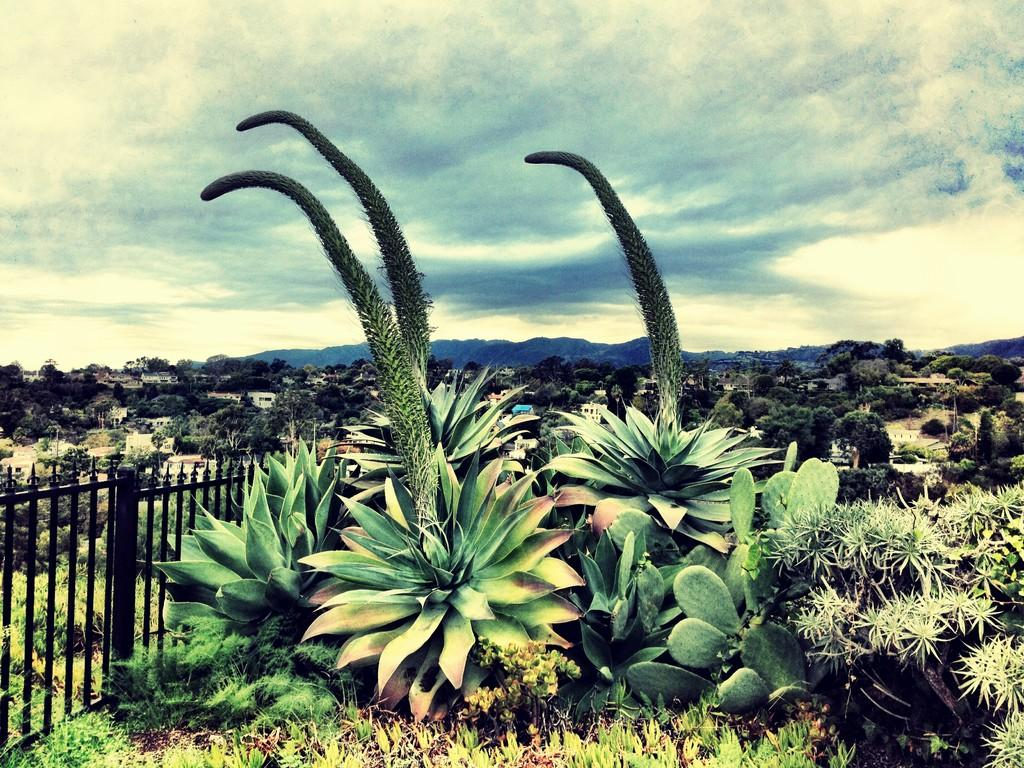What type of vegetation can be seen in the image? There are plants, grass, and trees in the image. What type of structures are present in the image? There are houses in the image. What natural features can be seen in the image? There are hills in the image. What type of barrier is visible in the image? There is a fence in the image. What is visible in the sky in the image? The sky is visible in the image, and clouds are present. What type of cake is being served on the hill in the image? There is no cake present in the image; it features plants, grass, trees, houses, hills, a fence, and a sky with clouds. How many eggs can be seen in the image? There are no eggs present in the image. 